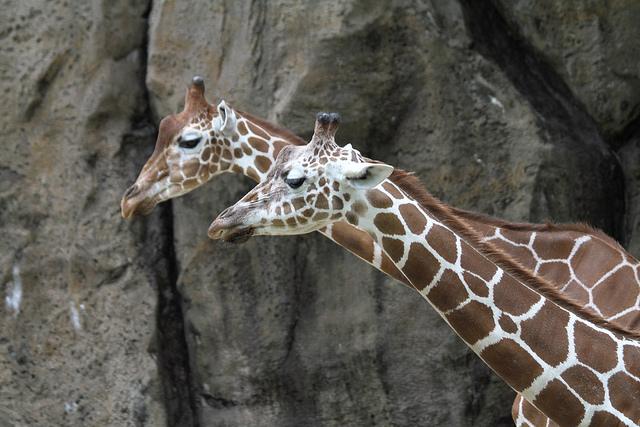Which animals are these?
Short answer required. Giraffes. Are the giraffes eating?
Short answer required. No. Is there a fence?
Concise answer only. No. Are the animals' whole bodies visible?
Quick response, please. No. Are the giraffes male or female?
Concise answer only. Male. Is there a pole?
Answer briefly. No. 